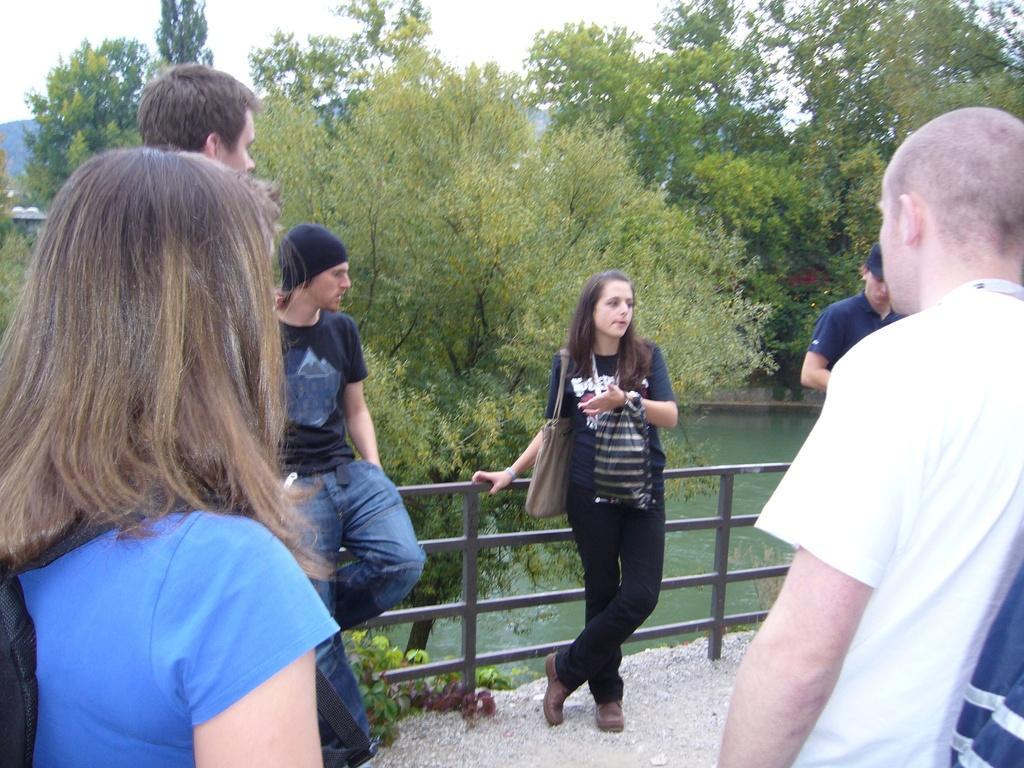How would you summarize this image in a sentence or two? In this picture we can see a woman carrying bag with her standing with holding fence and boy is leaning to the fence and remaining persons standing and watching them and in the background we can see trees, sky and a water and mostly this might be the bridge to cross water. 